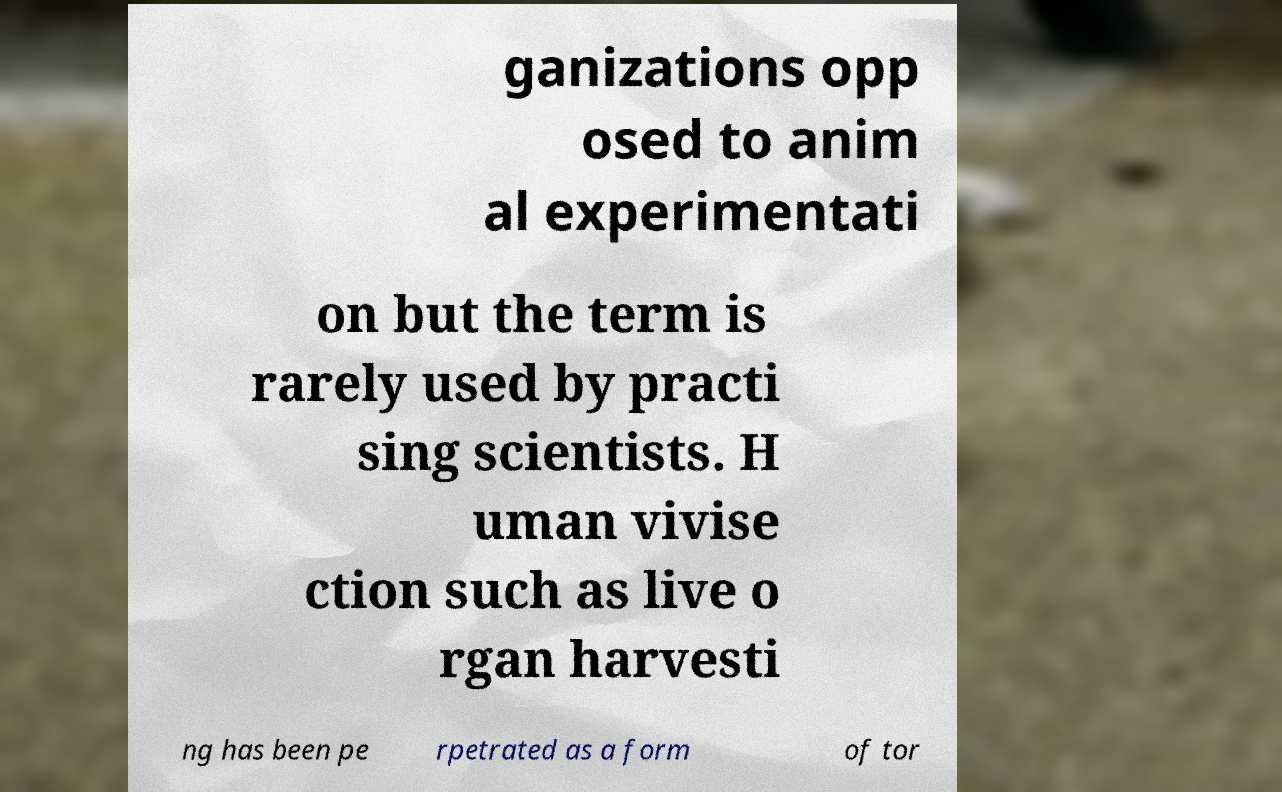Could you assist in decoding the text presented in this image and type it out clearly? ganizations opp osed to anim al experimentati on but the term is rarely used by practi sing scientists. H uman vivise ction such as live o rgan harvesti ng has been pe rpetrated as a form of tor 